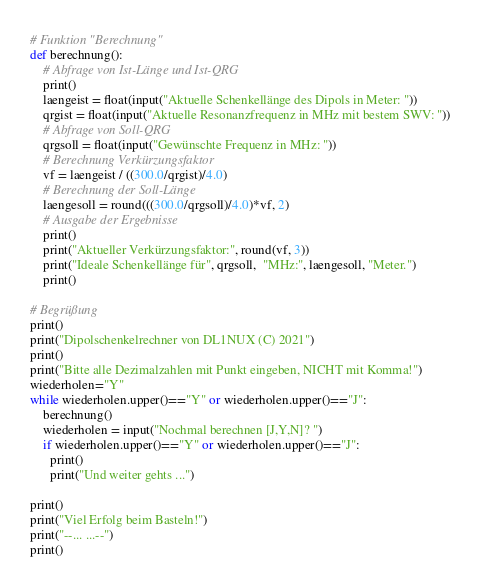<code> <loc_0><loc_0><loc_500><loc_500><_Python_># Funktion "Berechnung"
def berechnung():
    # Abfrage von Ist-Länge und Ist-QRG
    print()
    laengeist = float(input("Aktuelle Schenkellänge des Dipols in Meter: "))
    qrgist = float(input("Aktuelle Resonanzfrequenz in MHz mit bestem SWV: "))
    # Abfrage von Soll-QRG
    qrgsoll = float(input("Gewünschte Frequenz in MHz: "))
    # Berechnung Verkürzungsfaktor
    vf = laengeist / ((300.0/qrgist)/4.0)
    # Berechnung der Soll-Länge
    laengesoll = round(((300.0/qrgsoll)/4.0)*vf, 2)
    # Ausgabe der Ergebnisse
    print()
    print("Aktueller Verkürzungsfaktor:", round(vf, 3))
    print("Ideale Schenkellänge für", qrgsoll,  "MHz:", laengesoll, "Meter.")
    print()

# Begrüßung
print()
print("Dipolschenkelrechner von DL1NUX (C) 2021")
print()
print("Bitte alle Dezimalzahlen mit Punkt eingeben, NICHT mit Komma!")
wiederholen="Y"
while wiederholen.upper()=="Y" or wiederholen.upper()=="J":
    berechnung()
    wiederholen = input("Nochmal berechnen [J,Y,N]? ")
    if wiederholen.upper()=="Y" or wiederholen.upper()=="J":
      print()
      print("Und weiter gehts ...")
      
print()
print("Viel Erfolg beim Basteln!")
print("--... ...--")
print()</code> 